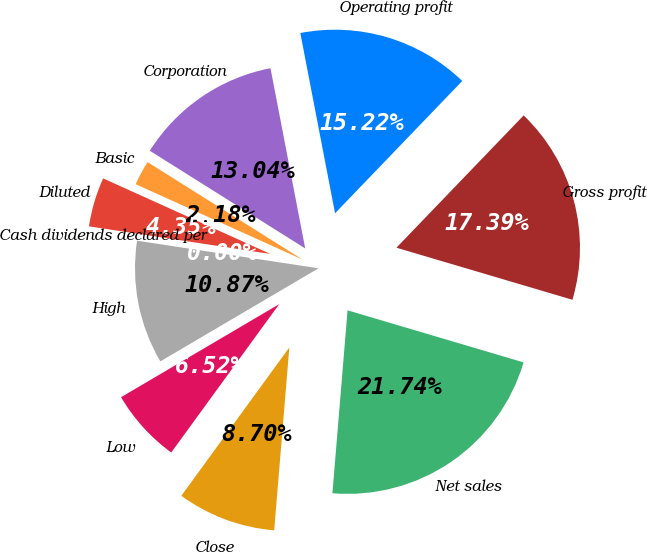Convert chart to OTSL. <chart><loc_0><loc_0><loc_500><loc_500><pie_chart><fcel>Net sales<fcel>Gross profit<fcel>Operating profit<fcel>Corporation<fcel>Basic<fcel>Diluted<fcel>Cash dividends declared per<fcel>High<fcel>Low<fcel>Close<nl><fcel>21.74%<fcel>17.39%<fcel>15.22%<fcel>13.04%<fcel>2.18%<fcel>4.35%<fcel>0.0%<fcel>10.87%<fcel>6.52%<fcel>8.7%<nl></chart> 